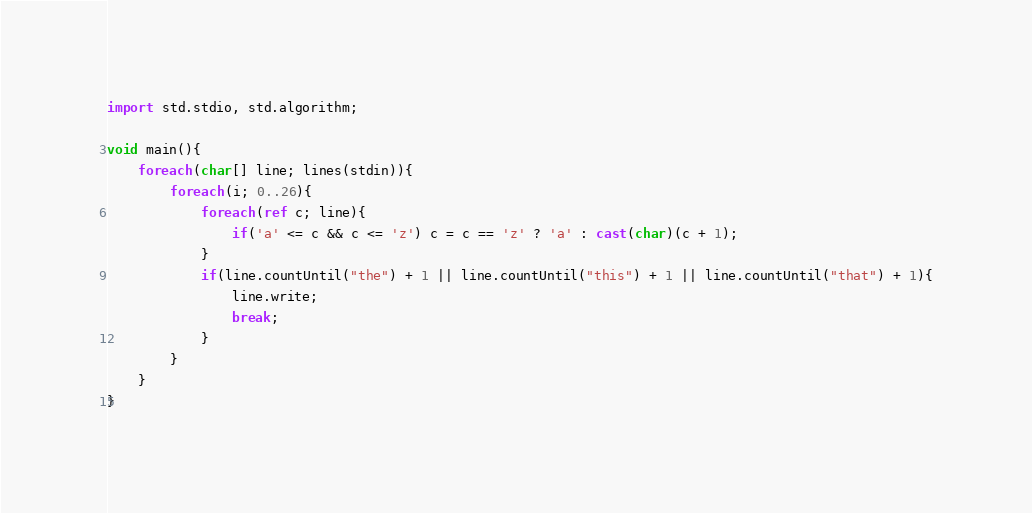Convert code to text. <code><loc_0><loc_0><loc_500><loc_500><_D_>import std.stdio, std.algorithm;

void main(){
    foreach(char[] line; lines(stdin)){
        foreach(i; 0..26){
			foreach(ref c; line){
                if('a' <= c && c <= 'z') c = c == 'z' ? 'a' : cast(char)(c + 1);
			}
            if(line.countUntil("the") + 1 || line.countUntil("this") + 1 || line.countUntil("that") + 1){
                line.write;
                break;
            }
        }
    }
}</code> 